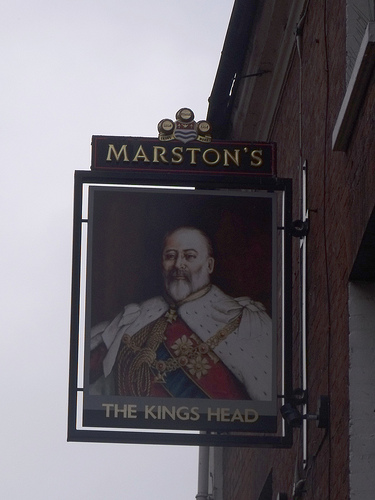<image>
Is the frame on the wall? Yes. Looking at the image, I can see the frame is positioned on top of the wall, with the wall providing support. Is the portrait in front of the sign? No. The portrait is not in front of the sign. The spatial positioning shows a different relationship between these objects. 